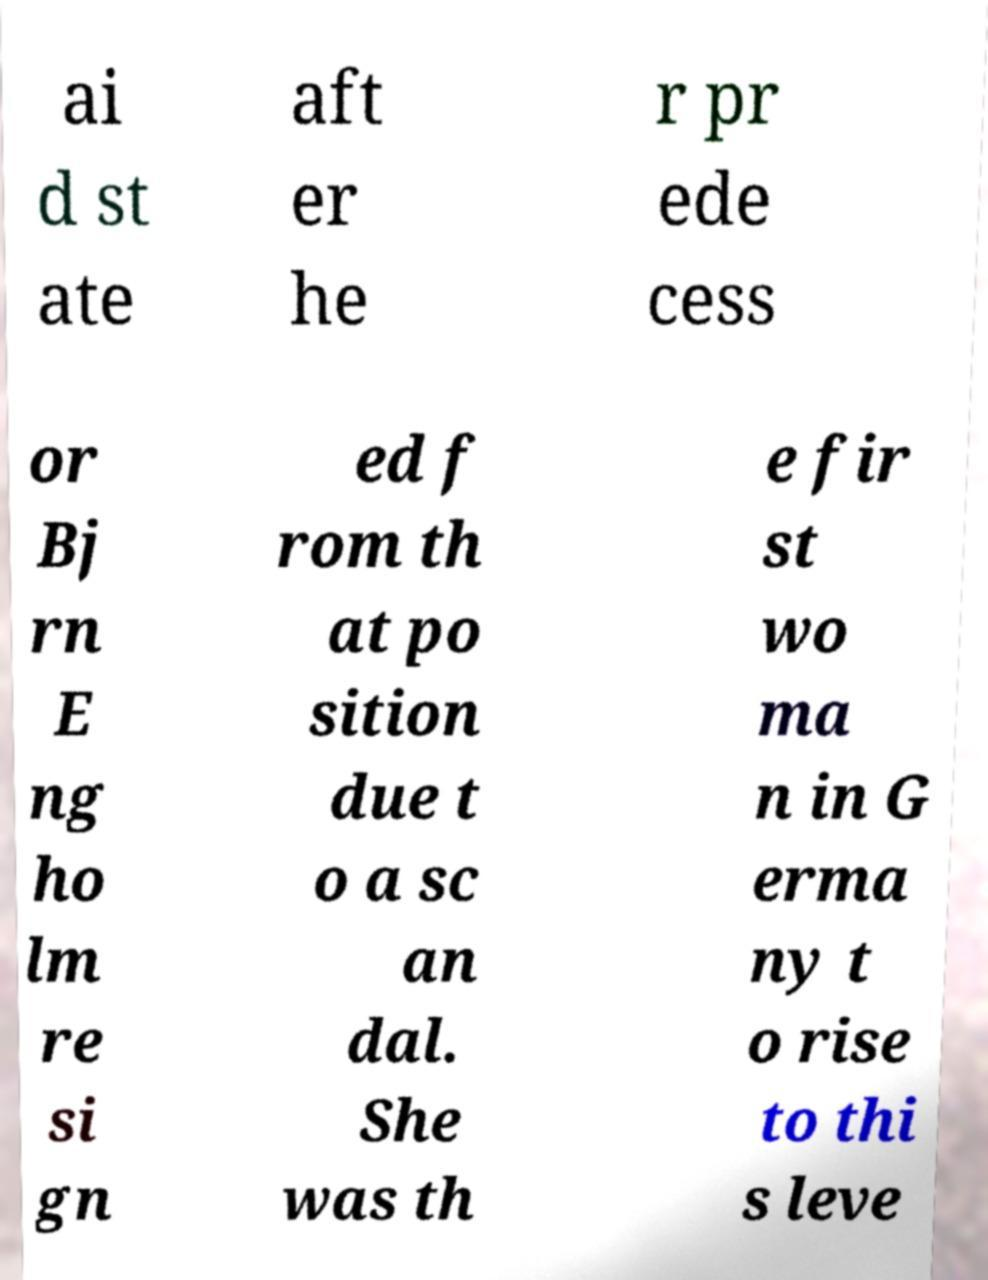I need the written content from this picture converted into text. Can you do that? ai d st ate aft er he r pr ede cess or Bj rn E ng ho lm re si gn ed f rom th at po sition due t o a sc an dal. She was th e fir st wo ma n in G erma ny t o rise to thi s leve 